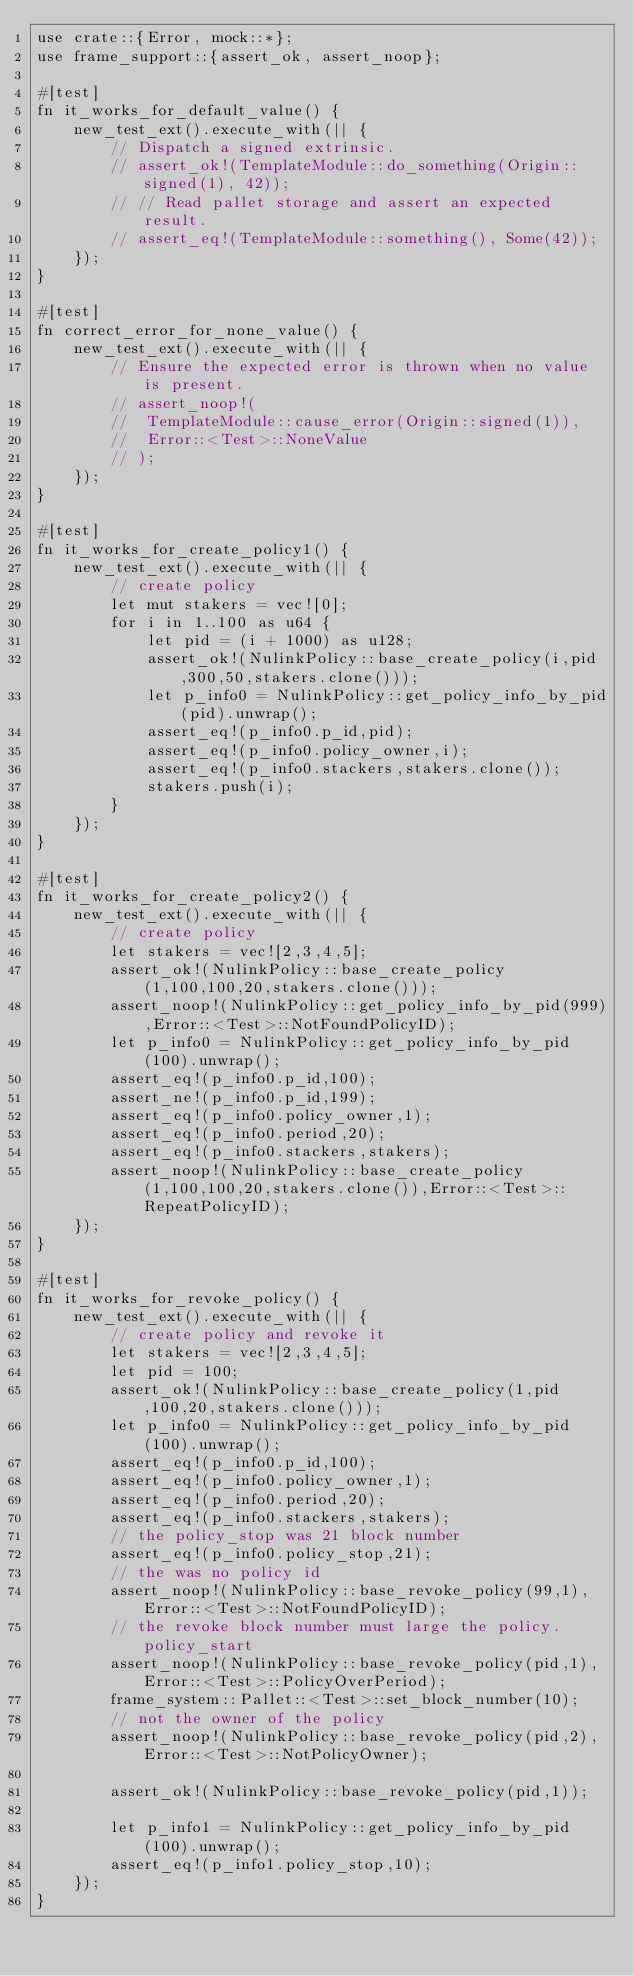<code> <loc_0><loc_0><loc_500><loc_500><_Rust_>use crate::{Error, mock::*};
use frame_support::{assert_ok, assert_noop};

#[test]
fn it_works_for_default_value() {
	new_test_ext().execute_with(|| {
		// Dispatch a signed extrinsic.
		// assert_ok!(TemplateModule::do_something(Origin::signed(1), 42));
		// // Read pallet storage and assert an expected result.
		// assert_eq!(TemplateModule::something(), Some(42));
	});
}

#[test]
fn correct_error_for_none_value() {
	new_test_ext().execute_with(|| {
		// Ensure the expected error is thrown when no value is present.
		// assert_noop!(
		// 	TemplateModule::cause_error(Origin::signed(1)),
		// 	Error::<Test>::NoneValue
		// );
	});
}

#[test]
fn it_works_for_create_policy1() {
	new_test_ext().execute_with(|| {
		// create policy
		let mut stakers = vec![0];
		for i in 1..100 as u64 {
			let pid = (i + 1000) as u128;
			assert_ok!(NulinkPolicy::base_create_policy(i,pid,300,50,stakers.clone()));
			let p_info0 = NulinkPolicy::get_policy_info_by_pid(pid).unwrap();
			assert_eq!(p_info0.p_id,pid);
			assert_eq!(p_info0.policy_owner,i);
			assert_eq!(p_info0.stackers,stakers.clone());
			stakers.push(i);
		}
	});
}

#[test]
fn it_works_for_create_policy2() {
	new_test_ext().execute_with(|| {
		// create policy
		let stakers = vec![2,3,4,5];
		assert_ok!(NulinkPolicy::base_create_policy(1,100,100,20,stakers.clone()));
		assert_noop!(NulinkPolicy::get_policy_info_by_pid(999),Error::<Test>::NotFoundPolicyID);
		let p_info0 = NulinkPolicy::get_policy_info_by_pid(100).unwrap();
		assert_eq!(p_info0.p_id,100);
		assert_ne!(p_info0.p_id,199);
		assert_eq!(p_info0.policy_owner,1);
		assert_eq!(p_info0.period,20);
		assert_eq!(p_info0.stackers,stakers);
		assert_noop!(NulinkPolicy::base_create_policy(1,100,100,20,stakers.clone()),Error::<Test>::RepeatPolicyID);
	});
}

#[test]
fn it_works_for_revoke_policy() {
	new_test_ext().execute_with(|| {
		// create policy and revoke it
		let stakers = vec![2,3,4,5];
		let pid = 100;
		assert_ok!(NulinkPolicy::base_create_policy(1,pid,100,20,stakers.clone()));
		let p_info0 = NulinkPolicy::get_policy_info_by_pid(100).unwrap();
		assert_eq!(p_info0.p_id,100);
		assert_eq!(p_info0.policy_owner,1);
		assert_eq!(p_info0.period,20);
		assert_eq!(p_info0.stackers,stakers);
		// the policy_stop was 21 block number
		assert_eq!(p_info0.policy_stop,21);
		// the was no policy id
		assert_noop!(NulinkPolicy::base_revoke_policy(99,1),Error::<Test>::NotFoundPolicyID);
		// the revoke block number must large the policy.policy_start
		assert_noop!(NulinkPolicy::base_revoke_policy(pid,1),Error::<Test>::PolicyOverPeriod);
		frame_system::Pallet::<Test>::set_block_number(10);
		// not the owner of the policy
		assert_noop!(NulinkPolicy::base_revoke_policy(pid,2),Error::<Test>::NotPolicyOwner);

		assert_ok!(NulinkPolicy::base_revoke_policy(pid,1));

		let p_info1 = NulinkPolicy::get_policy_info_by_pid(100).unwrap();
		assert_eq!(p_info1.policy_stop,10);
	});
}</code> 